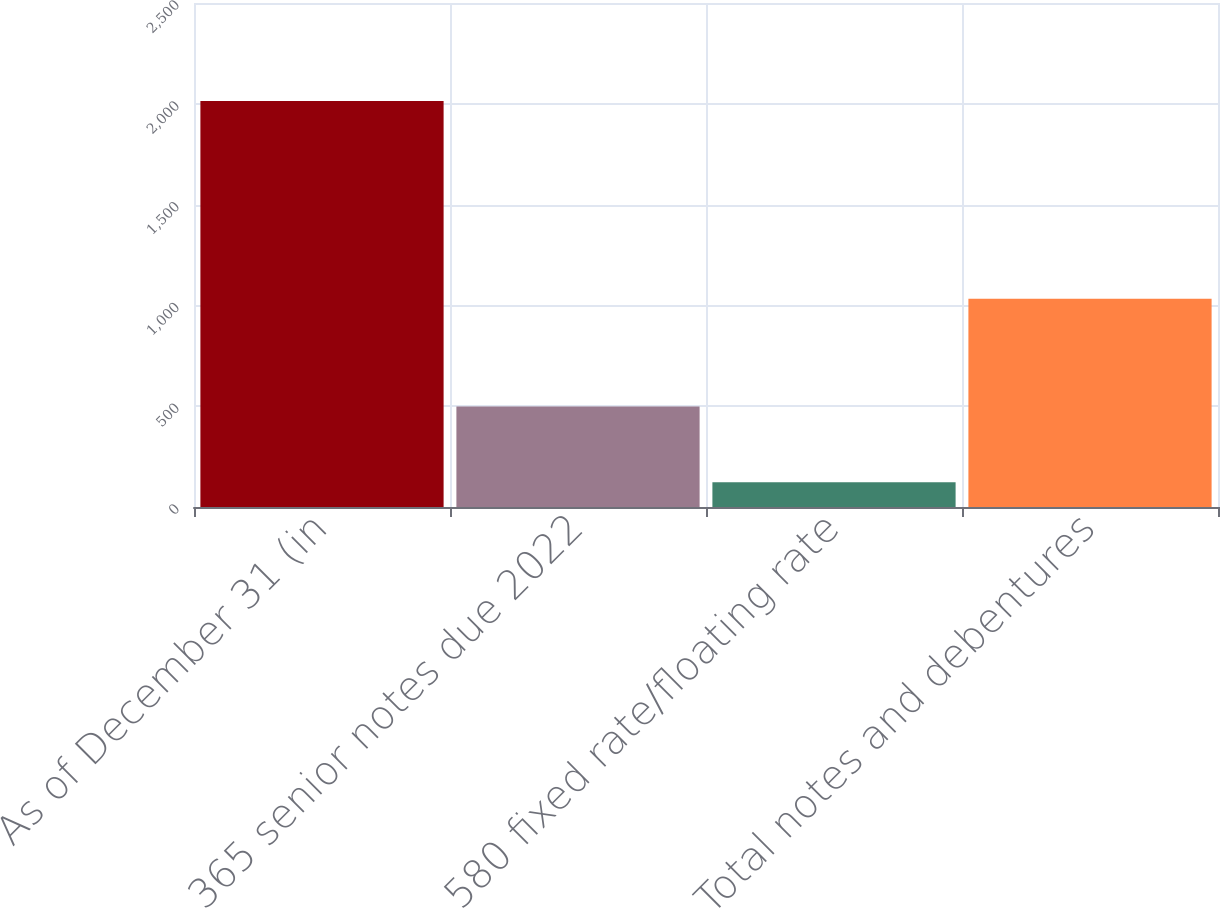<chart> <loc_0><loc_0><loc_500><loc_500><bar_chart><fcel>As of December 31 (in<fcel>365 senior notes due 2022<fcel>580 fixed rate/floating rate<fcel>Total notes and debentures<nl><fcel>2014<fcel>498.6<fcel>122.5<fcel>1033.5<nl></chart> 